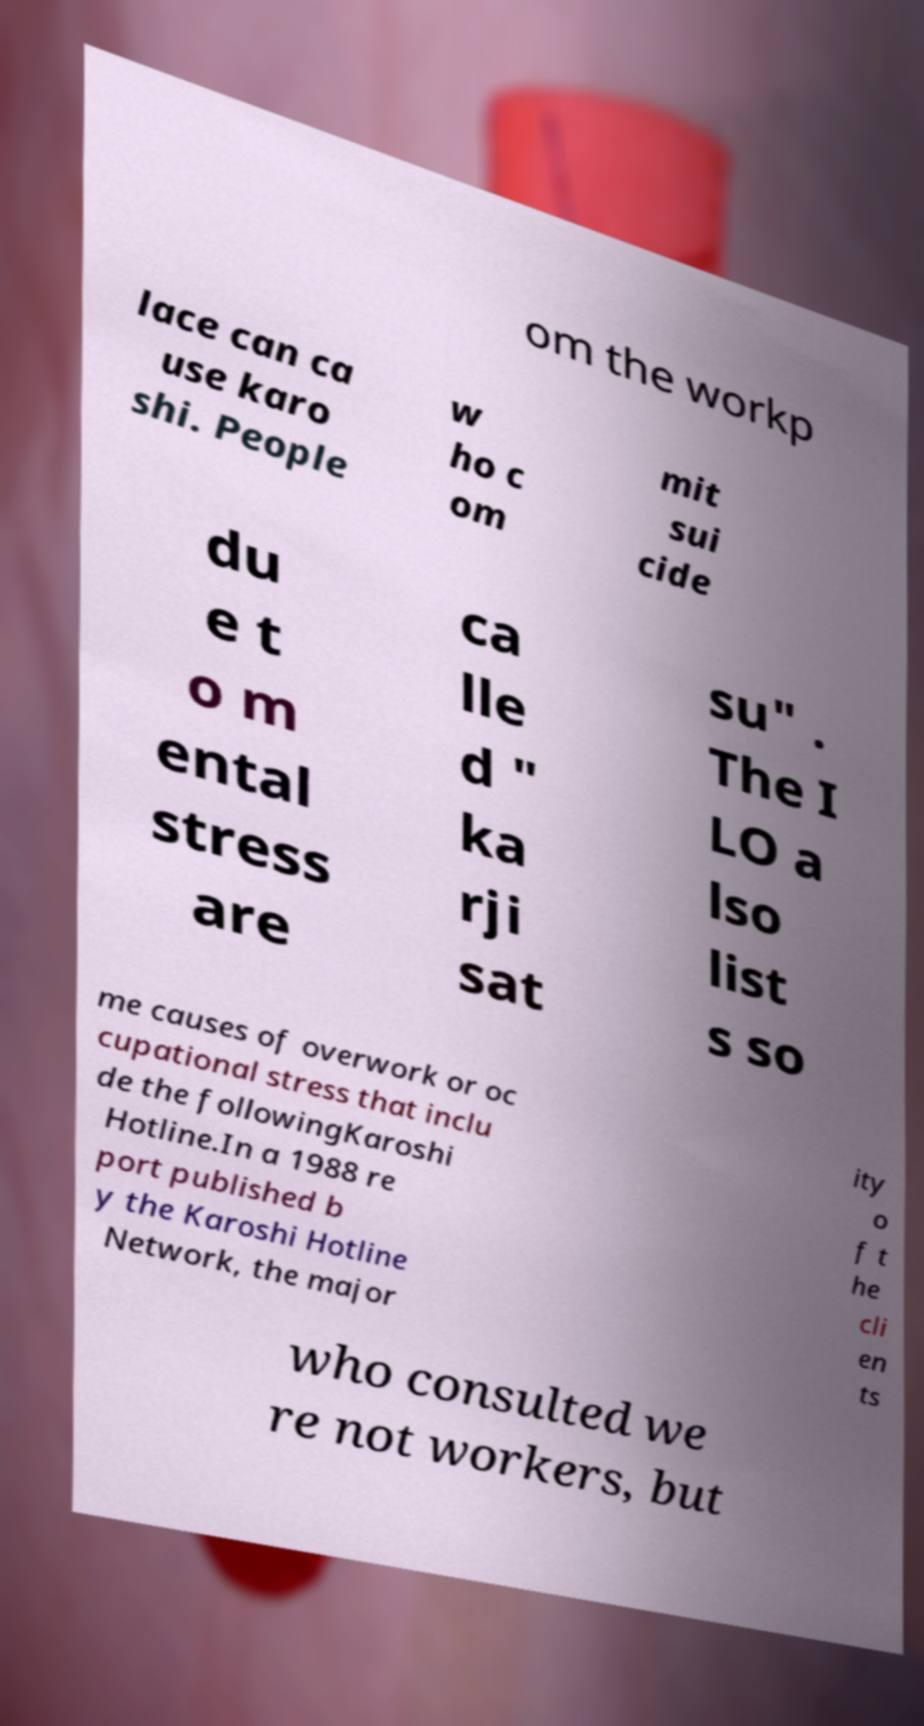What messages or text are displayed in this image? I need them in a readable, typed format. om the workp lace can ca use karo shi. People w ho c om mit sui cide du e t o m ental stress are ca lle d " ka rji sat su" . The I LO a lso list s so me causes of overwork or oc cupational stress that inclu de the followingKaroshi Hotline.In a 1988 re port published b y the Karoshi Hotline Network, the major ity o f t he cli en ts who consulted we re not workers, but 